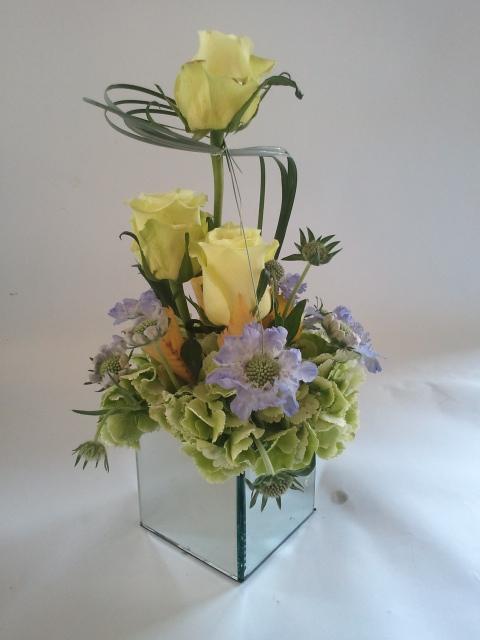How many roses are shown?
Give a very brief answer. 3. How many cats are laying down in the picture?
Give a very brief answer. 0. How many kites are in the sky?
Give a very brief answer. 0. 